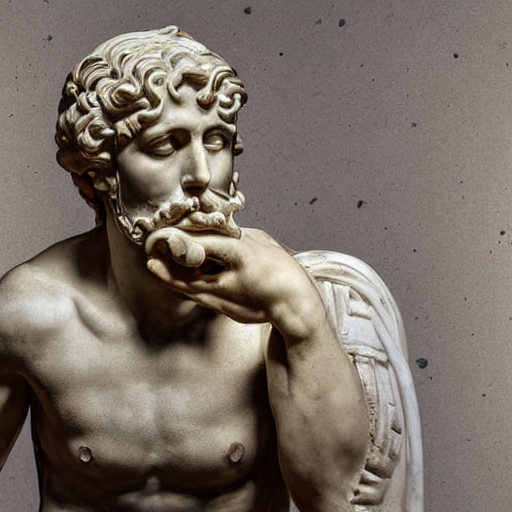What style or period does this sculpture represent? This sculpture is reminiscent of classical antiquity, specifically the works that originated in ancient Greece or Rome. Its naturalism and idealized form suggest it could be attributed to the Hellenistic or Roman Imperial period. 